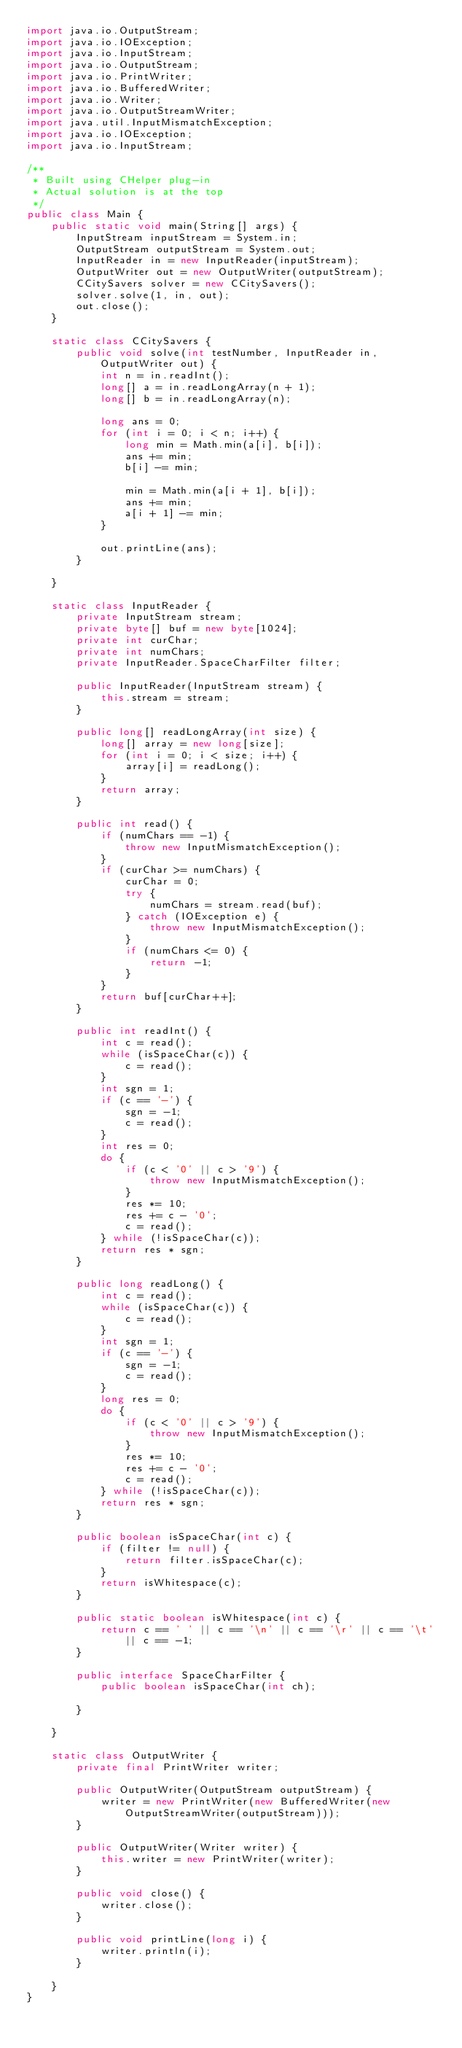Convert code to text. <code><loc_0><loc_0><loc_500><loc_500><_Java_>import java.io.OutputStream;
import java.io.IOException;
import java.io.InputStream;
import java.io.OutputStream;
import java.io.PrintWriter;
import java.io.BufferedWriter;
import java.io.Writer;
import java.io.OutputStreamWriter;
import java.util.InputMismatchException;
import java.io.IOException;
import java.io.InputStream;

/**
 * Built using CHelper plug-in
 * Actual solution is at the top
 */
public class Main {
    public static void main(String[] args) {
        InputStream inputStream = System.in;
        OutputStream outputStream = System.out;
        InputReader in = new InputReader(inputStream);
        OutputWriter out = new OutputWriter(outputStream);
        CCitySavers solver = new CCitySavers();
        solver.solve(1, in, out);
        out.close();
    }

    static class CCitySavers {
        public void solve(int testNumber, InputReader in, OutputWriter out) {
            int n = in.readInt();
            long[] a = in.readLongArray(n + 1);
            long[] b = in.readLongArray(n);

            long ans = 0;
            for (int i = 0; i < n; i++) {
                long min = Math.min(a[i], b[i]);
                ans += min;
                b[i] -= min;

                min = Math.min(a[i + 1], b[i]);
                ans += min;
                a[i + 1] -= min;
            }

            out.printLine(ans);
        }

    }

    static class InputReader {
        private InputStream stream;
        private byte[] buf = new byte[1024];
        private int curChar;
        private int numChars;
        private InputReader.SpaceCharFilter filter;

        public InputReader(InputStream stream) {
            this.stream = stream;
        }

        public long[] readLongArray(int size) {
            long[] array = new long[size];
            for (int i = 0; i < size; i++) {
                array[i] = readLong();
            }
            return array;
        }

        public int read() {
            if (numChars == -1) {
                throw new InputMismatchException();
            }
            if (curChar >= numChars) {
                curChar = 0;
                try {
                    numChars = stream.read(buf);
                } catch (IOException e) {
                    throw new InputMismatchException();
                }
                if (numChars <= 0) {
                    return -1;
                }
            }
            return buf[curChar++];
        }

        public int readInt() {
            int c = read();
            while (isSpaceChar(c)) {
                c = read();
            }
            int sgn = 1;
            if (c == '-') {
                sgn = -1;
                c = read();
            }
            int res = 0;
            do {
                if (c < '0' || c > '9') {
                    throw new InputMismatchException();
                }
                res *= 10;
                res += c - '0';
                c = read();
            } while (!isSpaceChar(c));
            return res * sgn;
        }

        public long readLong() {
            int c = read();
            while (isSpaceChar(c)) {
                c = read();
            }
            int sgn = 1;
            if (c == '-') {
                sgn = -1;
                c = read();
            }
            long res = 0;
            do {
                if (c < '0' || c > '9') {
                    throw new InputMismatchException();
                }
                res *= 10;
                res += c - '0';
                c = read();
            } while (!isSpaceChar(c));
            return res * sgn;
        }

        public boolean isSpaceChar(int c) {
            if (filter != null) {
                return filter.isSpaceChar(c);
            }
            return isWhitespace(c);
        }

        public static boolean isWhitespace(int c) {
            return c == ' ' || c == '\n' || c == '\r' || c == '\t' || c == -1;
        }

        public interface SpaceCharFilter {
            public boolean isSpaceChar(int ch);

        }

    }

    static class OutputWriter {
        private final PrintWriter writer;

        public OutputWriter(OutputStream outputStream) {
            writer = new PrintWriter(new BufferedWriter(new OutputStreamWriter(outputStream)));
        }

        public OutputWriter(Writer writer) {
            this.writer = new PrintWriter(writer);
        }

        public void close() {
            writer.close();
        }

        public void printLine(long i) {
            writer.println(i);
        }

    }
}

</code> 